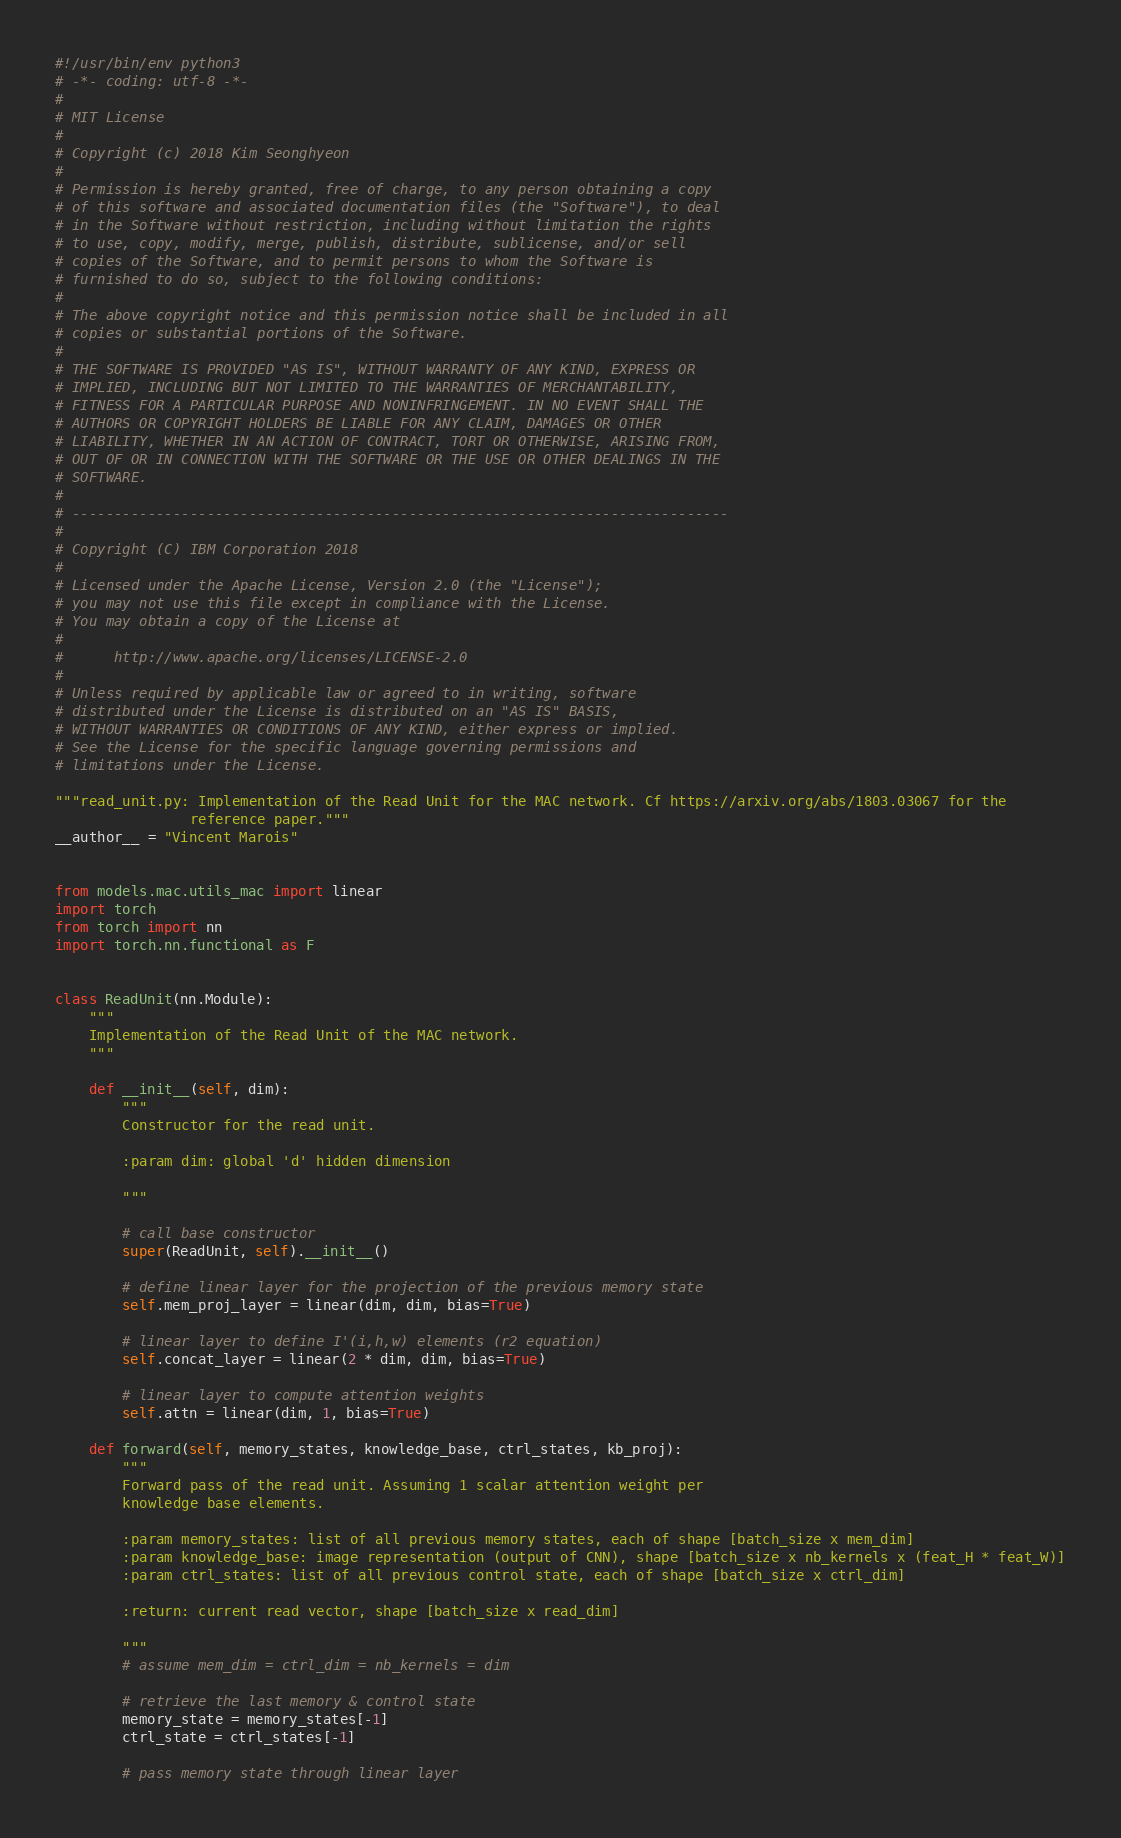<code> <loc_0><loc_0><loc_500><loc_500><_Python_>#!/usr/bin/env python3
# -*- coding: utf-8 -*-
#
# MIT License
#
# Copyright (c) 2018 Kim Seonghyeon
#
# Permission is hereby granted, free of charge, to any person obtaining a copy
# of this software and associated documentation files (the "Software"), to deal
# in the Software without restriction, including without limitation the rights
# to use, copy, modify, merge, publish, distribute, sublicense, and/or sell
# copies of the Software, and to permit persons to whom the Software is
# furnished to do so, subject to the following conditions:
#
# The above copyright notice and this permission notice shall be included in all
# copies or substantial portions of the Software.
#
# THE SOFTWARE IS PROVIDED "AS IS", WITHOUT WARRANTY OF ANY KIND, EXPRESS OR
# IMPLIED, INCLUDING BUT NOT LIMITED TO THE WARRANTIES OF MERCHANTABILITY,
# FITNESS FOR A PARTICULAR PURPOSE AND NONINFRINGEMENT. IN NO EVENT SHALL THE
# AUTHORS OR COPYRIGHT HOLDERS BE LIABLE FOR ANY CLAIM, DAMAGES OR OTHER
# LIABILITY, WHETHER IN AN ACTION OF CONTRACT, TORT OR OTHERWISE, ARISING FROM,
# OUT OF OR IN CONNECTION WITH THE SOFTWARE OR THE USE OR OTHER DEALINGS IN THE
# SOFTWARE.
#
# ------------------------------------------------------------------------------
#
# Copyright (C) IBM Corporation 2018
#
# Licensed under the Apache License, Version 2.0 (the "License");
# you may not use this file except in compliance with the License.
# You may obtain a copy of the License at
#
#      http://www.apache.org/licenses/LICENSE-2.0
#
# Unless required by applicable law or agreed to in writing, software
# distributed under the License is distributed on an "AS IS" BASIS,
# WITHOUT WARRANTIES OR CONDITIONS OF ANY KIND, either express or implied.
# See the License for the specific language governing permissions and
# limitations under the License.

"""read_unit.py: Implementation of the Read Unit for the MAC network. Cf https://arxiv.org/abs/1803.03067 for the
                reference paper."""
__author__ = "Vincent Marois"


from models.mac.utils_mac import linear
import torch
from torch import nn
import torch.nn.functional as F


class ReadUnit(nn.Module):
    """
    Implementation of the Read Unit of the MAC network.
    """

    def __init__(self, dim):
        """
        Constructor for the read unit.

        :param dim: global 'd' hidden dimension

        """

        # call base constructor
        super(ReadUnit, self).__init__()

        # define linear layer for the projection of the previous memory state
        self.mem_proj_layer = linear(dim, dim, bias=True)

        # linear layer to define I'(i,h,w) elements (r2 equation)
        self.concat_layer = linear(2 * dim, dim, bias=True)

        # linear layer to compute attention weights
        self.attn = linear(dim, 1, bias=True)

    def forward(self, memory_states, knowledge_base, ctrl_states, kb_proj):
        """
        Forward pass of the read unit. Assuming 1 scalar attention weight per
        knowledge base elements.

        :param memory_states: list of all previous memory states, each of shape [batch_size x mem_dim]
        :param knowledge_base: image representation (output of CNN), shape [batch_size x nb_kernels x (feat_H * feat_W)]
        :param ctrl_states: list of all previous control state, each of shape [batch_size x ctrl_dim]

        :return: current read vector, shape [batch_size x read_dim]

        """
        # assume mem_dim = ctrl_dim = nb_kernels = dim

        # retrieve the last memory & control state
        memory_state = memory_states[-1]
        ctrl_state = ctrl_states[-1]

        # pass memory state through linear layer</code> 